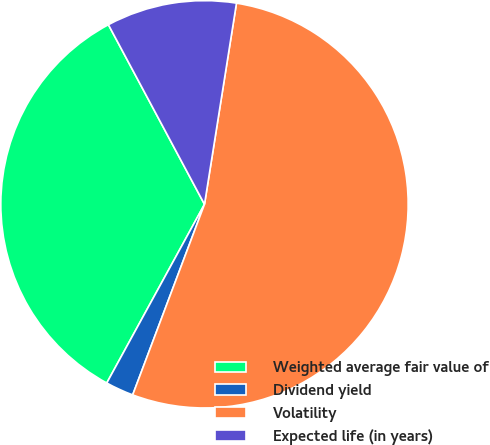Convert chart. <chart><loc_0><loc_0><loc_500><loc_500><pie_chart><fcel>Weighted average fair value of<fcel>Dividend yield<fcel>Volatility<fcel>Expected life (in years)<nl><fcel>34.22%<fcel>2.23%<fcel>53.23%<fcel>10.33%<nl></chart> 